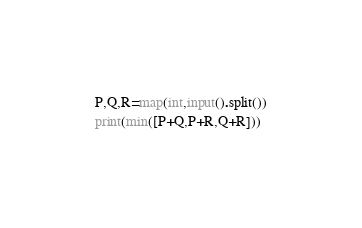<code> <loc_0><loc_0><loc_500><loc_500><_Python_>P,Q,R=map(int,input().split())
print(min([P+Q,P+R,Q+R]))</code> 